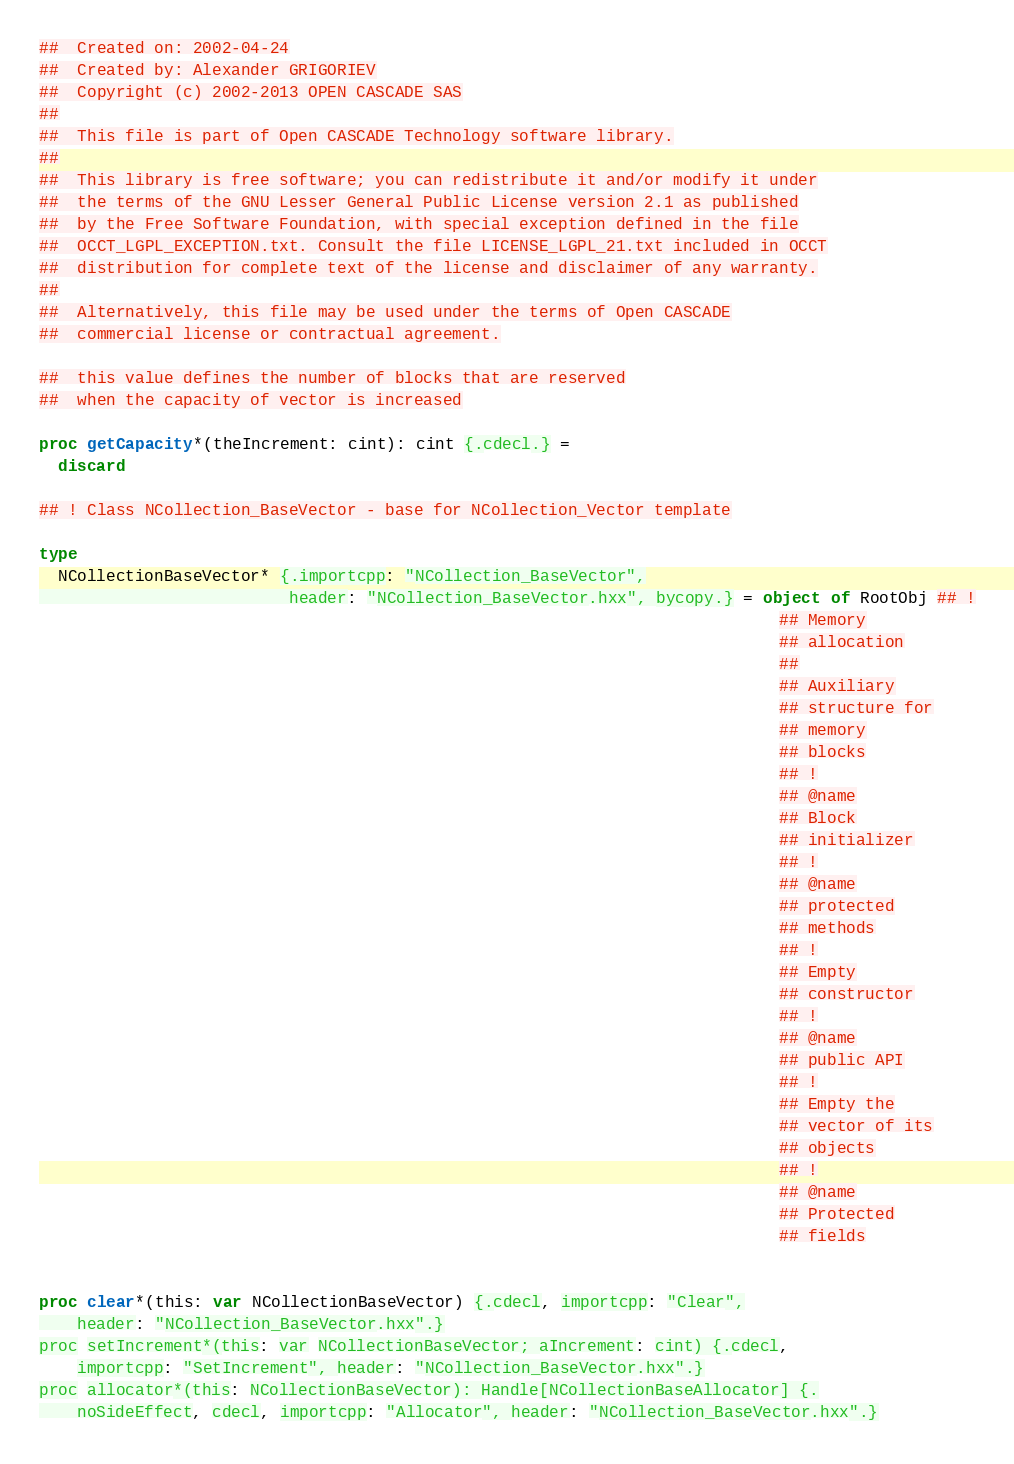<code> <loc_0><loc_0><loc_500><loc_500><_Nim_>##  Created on: 2002-04-24
##  Created by: Alexander GRIGORIEV
##  Copyright (c) 2002-2013 OPEN CASCADE SAS
##
##  This file is part of Open CASCADE Technology software library.
##
##  This library is free software; you can redistribute it and/or modify it under
##  the terms of the GNU Lesser General Public License version 2.1 as published
##  by the Free Software Foundation, with special exception defined in the file
##  OCCT_LGPL_EXCEPTION.txt. Consult the file LICENSE_LGPL_21.txt included in OCCT
##  distribution for complete text of the license and disclaimer of any warranty.
##
##  Alternatively, this file may be used under the terms of Open CASCADE
##  commercial license or contractual agreement.

##  this value defines the number of blocks that are reserved
##  when the capacity of vector is increased

proc getCapacity*(theIncrement: cint): cint {.cdecl.} =
  discard

## ! Class NCollection_BaseVector - base for NCollection_Vector template

type
  NCollectionBaseVector* {.importcpp: "NCollection_BaseVector",
                          header: "NCollection_BaseVector.hxx", bycopy.} = object of RootObj ## !
                                                                             ## Memory
                                                                             ## allocation
                                                                             ##
                                                                             ## Auxiliary
                                                                             ## structure for
                                                                             ## memory
                                                                             ## blocks
                                                                             ## !
                                                                             ## @name
                                                                             ## Block
                                                                             ## initializer
                                                                             ## !
                                                                             ## @name
                                                                             ## protected
                                                                             ## methods
                                                                             ## !
                                                                             ## Empty
                                                                             ## constructor
                                                                             ## !
                                                                             ## @name
                                                                             ## public API
                                                                             ## !
                                                                             ## Empty the
                                                                             ## vector of its
                                                                             ## objects
                                                                             ## !
                                                                             ## @name
                                                                             ## Protected
                                                                             ## fields


proc clear*(this: var NCollectionBaseVector) {.cdecl, importcpp: "Clear",
    header: "NCollection_BaseVector.hxx".}
proc setIncrement*(this: var NCollectionBaseVector; aIncrement: cint) {.cdecl,
    importcpp: "SetIncrement", header: "NCollection_BaseVector.hxx".}
proc allocator*(this: NCollectionBaseVector): Handle[NCollectionBaseAllocator] {.
    noSideEffect, cdecl, importcpp: "Allocator", header: "NCollection_BaseVector.hxx".}</code> 